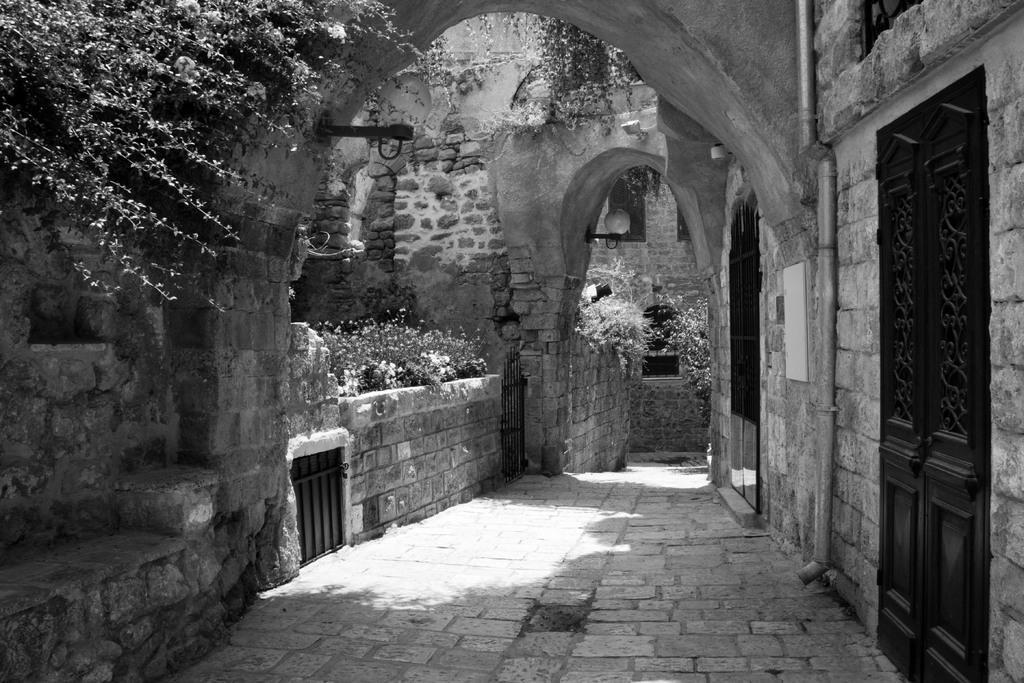Could you give a brief overview of what you see in this image? In the image we can see stone construction, this is a fence, grass, tree, pipe, footpath and a door. 